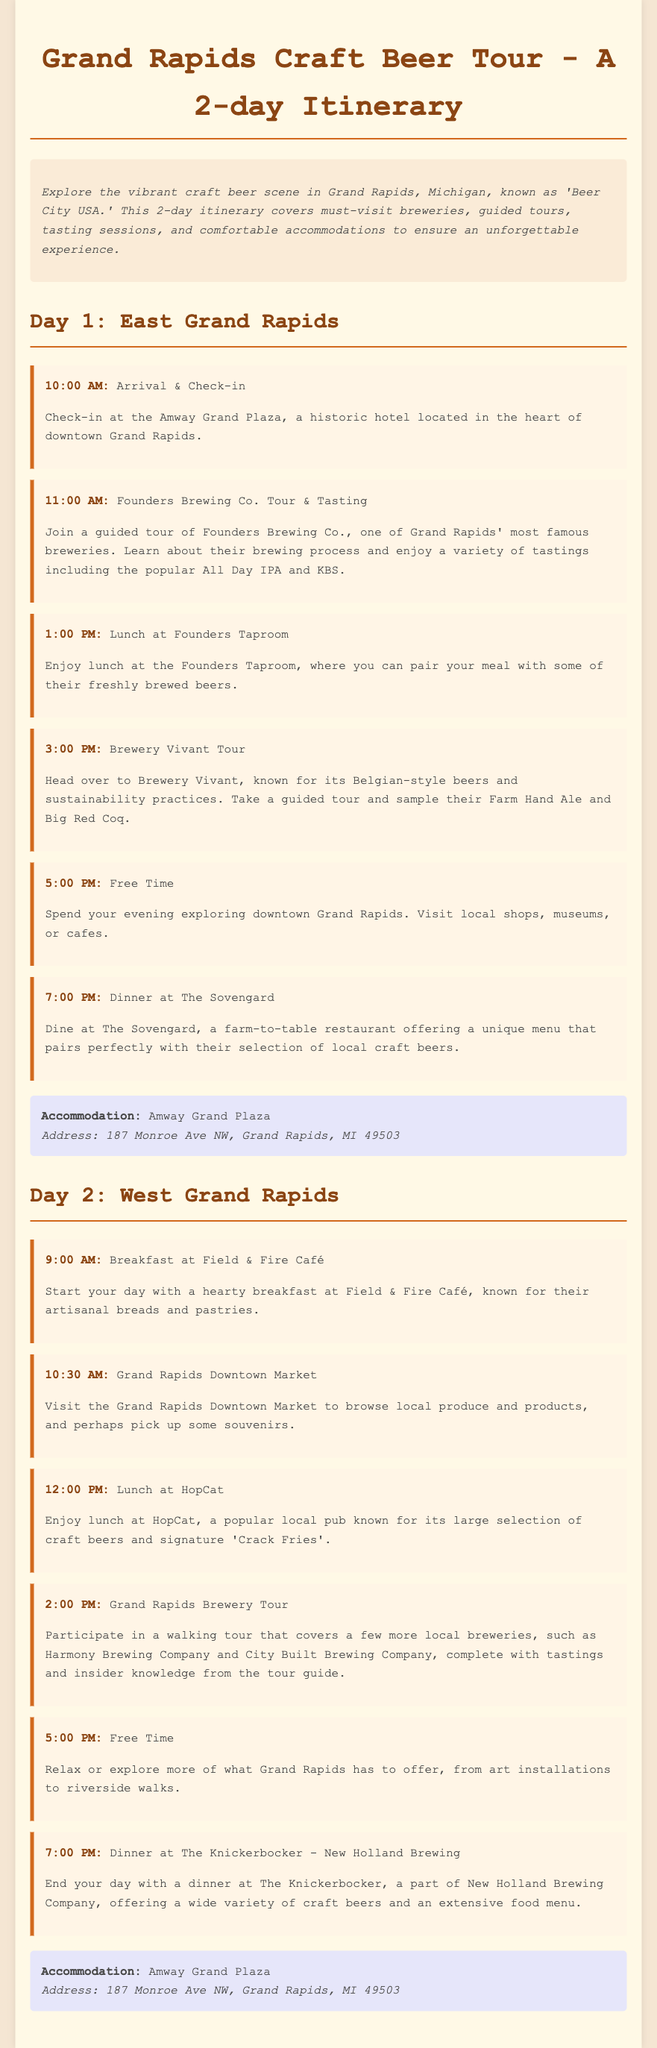What is the name of the historic hotel for check-in? The document specifies that the Amway Grand Plaza is the hotel for check-in, a historic hotel in downtown Grand Rapids.
Answer: Amway Grand Plaza What is the first activity on Day 1? The document outlines the itinerary starting with check-in at 10:00 AM, followed by a guided tour at Founders Brewing Co.
Answer: Founders Brewing Co. Tour & Tasting What time does lunch occur on Day 1? According to the itinerary, lunch at the Founders Taproom is scheduled for 1:00 PM.
Answer: 1:00 PM Which brewery is known for its Belgian-style beers? The document mentions that Brewery Vivant is known for its Belgian-style beers and sustainability practices.
Answer: Brewery Vivant What is the last activity on Day 2? The itinerary indicates that the last activity on Day 2 is dinner at The Knickerbocker.
Answer: Dinner at The Knickerbocker How many breweries are mentioned in the Grand Rapids Brewery Tour? The itinerary refers to a walking tour that includes Harmony Brewing Company and City Built Brewing Company, totaling two breweries.
Answer: 2 What type of restaurant is The Sovengard? The document describes The Sovengard as a farm-to-table restaurant offering a unique menu and local craft beers.
Answer: Farm-to-table What is highlighted as a popular local pub for lunch on Day 2? The itinerary highlights HopCat as a popular local pub known for its craft beers and signature 'Crack Fries'.
Answer: HopCat 